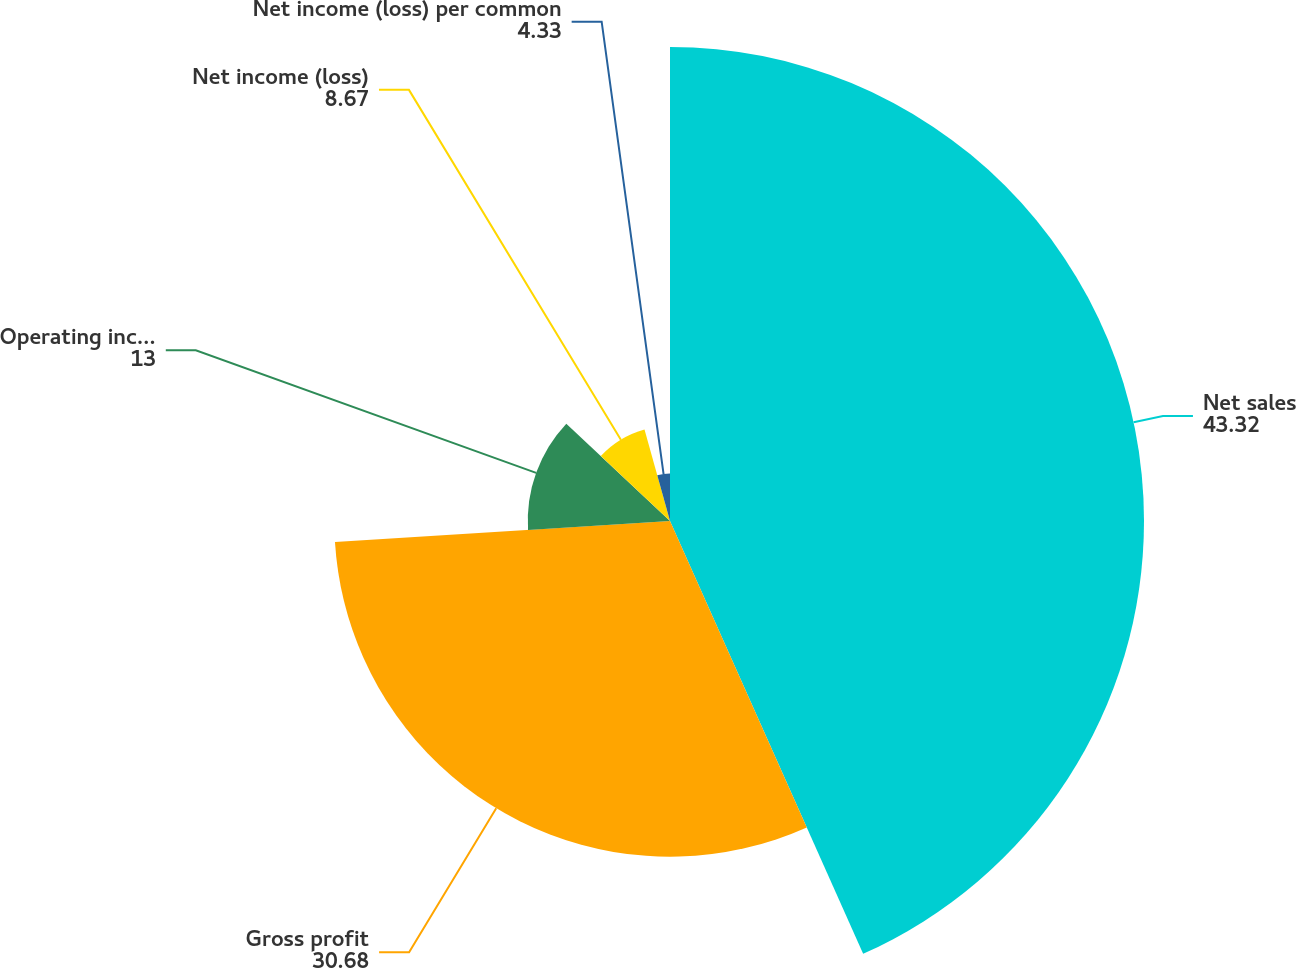Convert chart. <chart><loc_0><loc_0><loc_500><loc_500><pie_chart><fcel>Net sales<fcel>Gross profit<fcel>Operating income (loss)<fcel>Net income (loss)<fcel>Net income (loss) per common<nl><fcel>43.32%<fcel>30.68%<fcel>13.0%<fcel>8.67%<fcel>4.33%<nl></chart> 